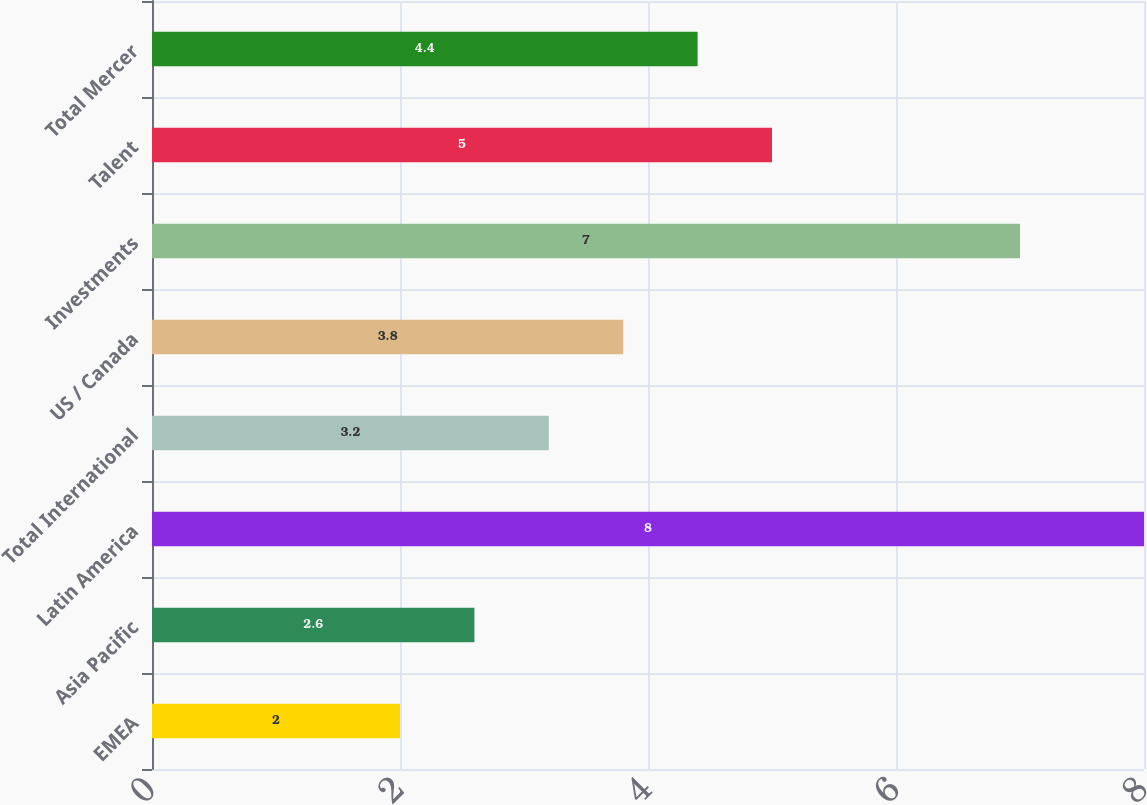Convert chart. <chart><loc_0><loc_0><loc_500><loc_500><bar_chart><fcel>EMEA<fcel>Asia Pacific<fcel>Latin America<fcel>Total International<fcel>US / Canada<fcel>Investments<fcel>Talent<fcel>Total Mercer<nl><fcel>2<fcel>2.6<fcel>8<fcel>3.2<fcel>3.8<fcel>7<fcel>5<fcel>4.4<nl></chart> 